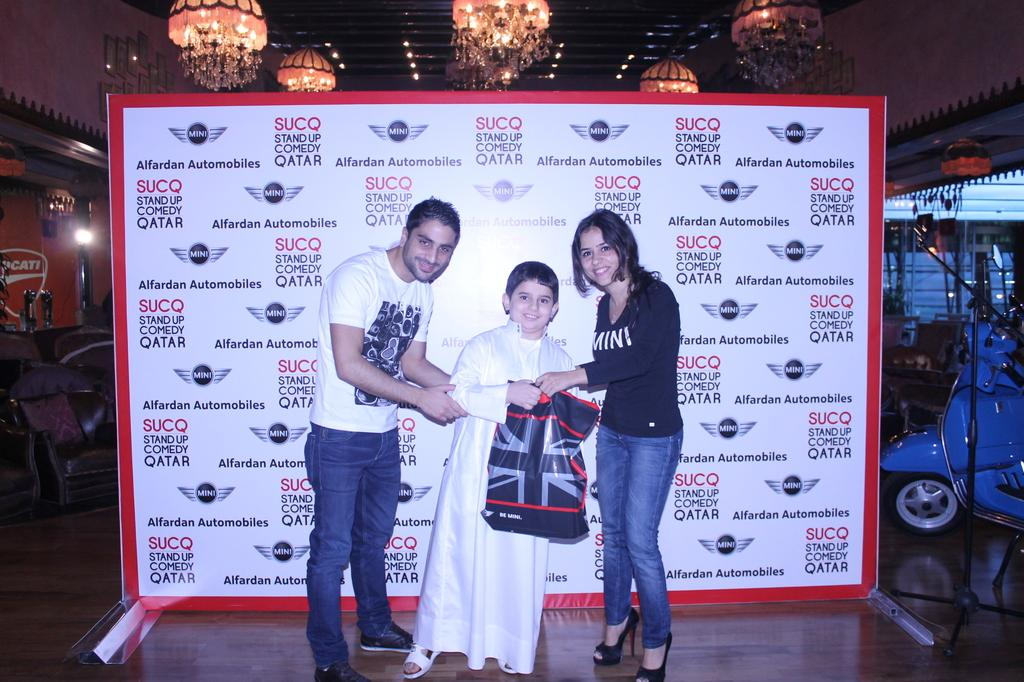<image>
Give a short and clear explanation of the subsequent image. People perform on a small stage at a stand-up comedy event sponsored by Mini. 